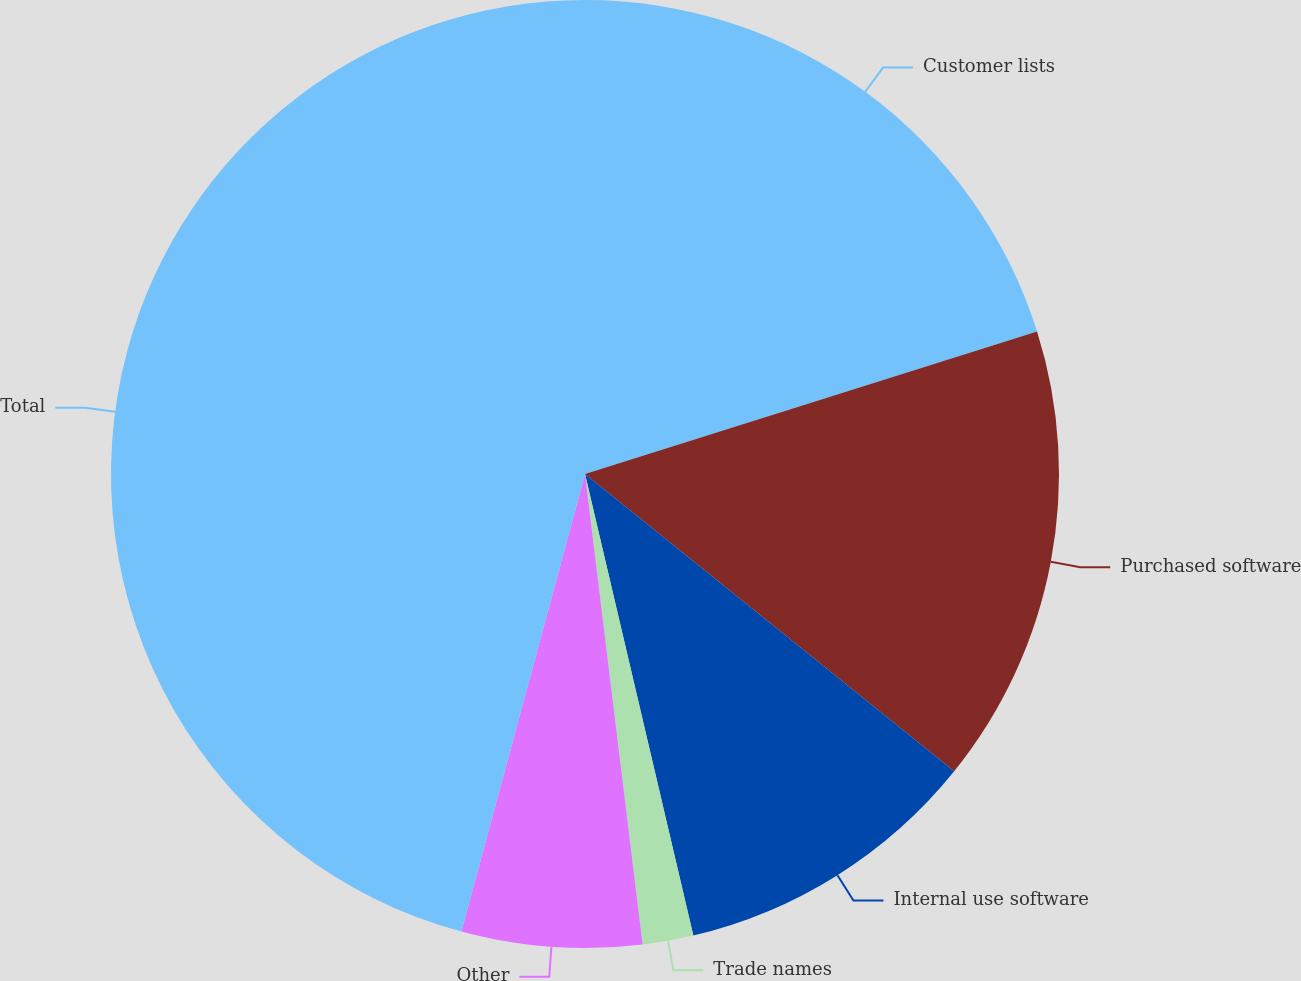<chart> <loc_0><loc_0><loc_500><loc_500><pie_chart><fcel>Customer lists<fcel>Purchased software<fcel>Internal use software<fcel>Trade names<fcel>Other<fcel>Total<nl><fcel>20.14%<fcel>15.65%<fcel>10.54%<fcel>1.73%<fcel>6.14%<fcel>45.8%<nl></chart> 